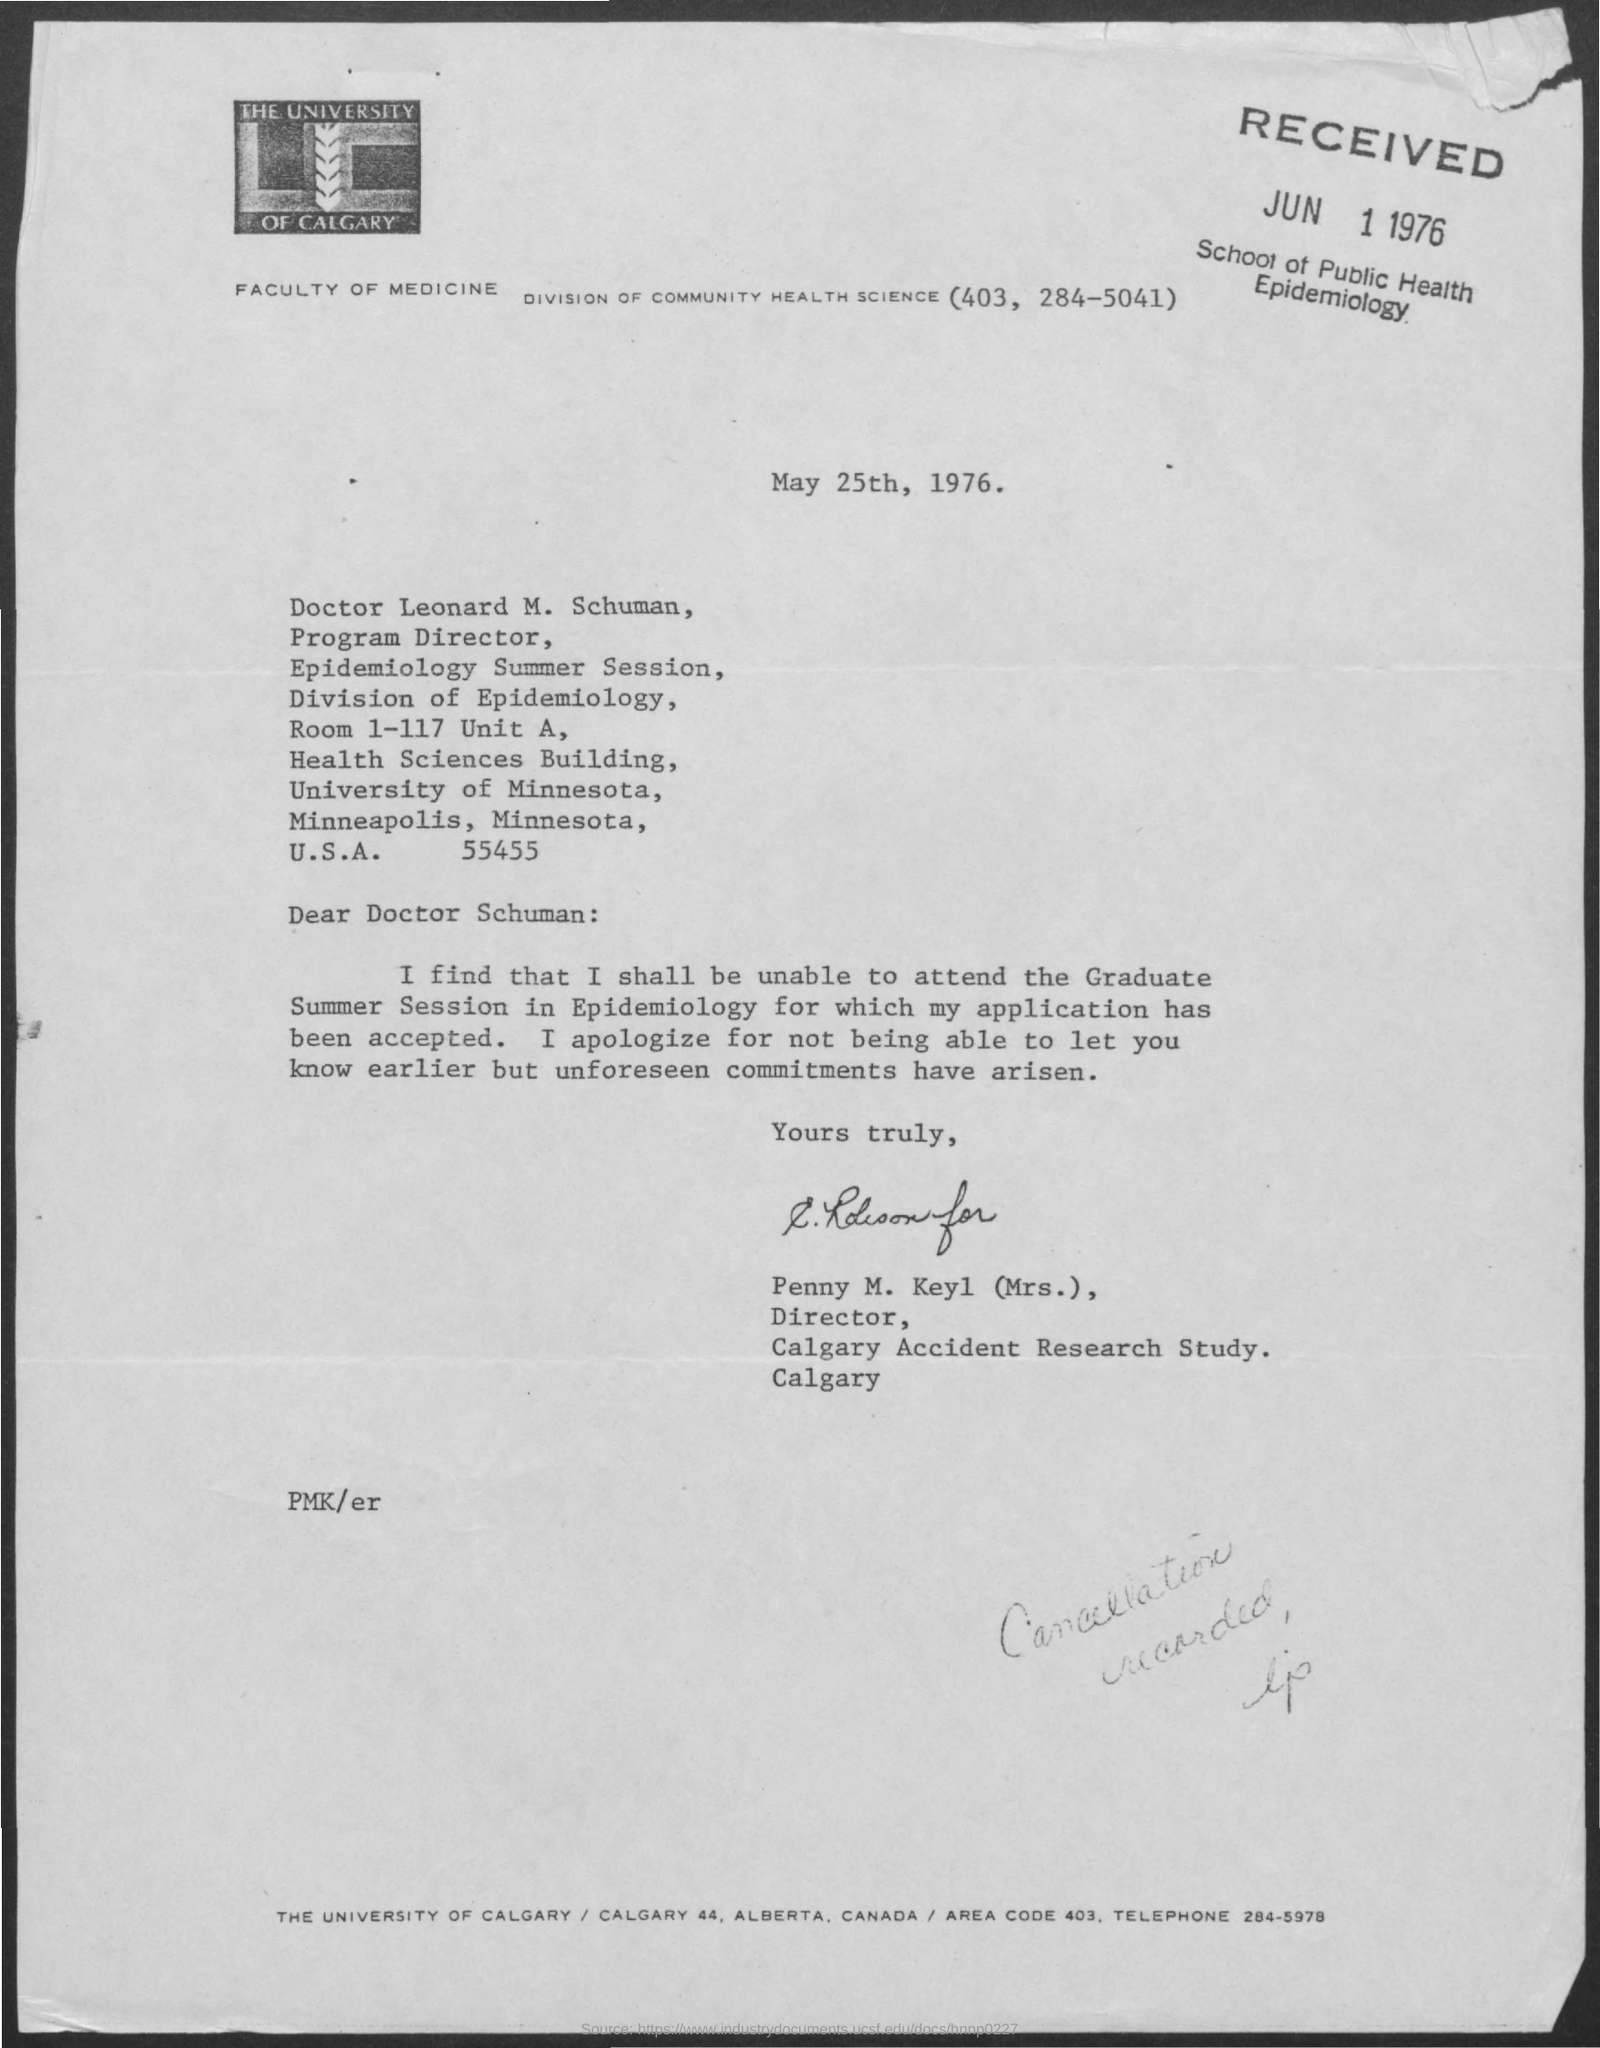Point out several critical features in this image. The letter head mentions "The University of Calgary. The issued date of this letter is May 25th, 1976. The letter is from Mrs. Penny M. Keyl. 